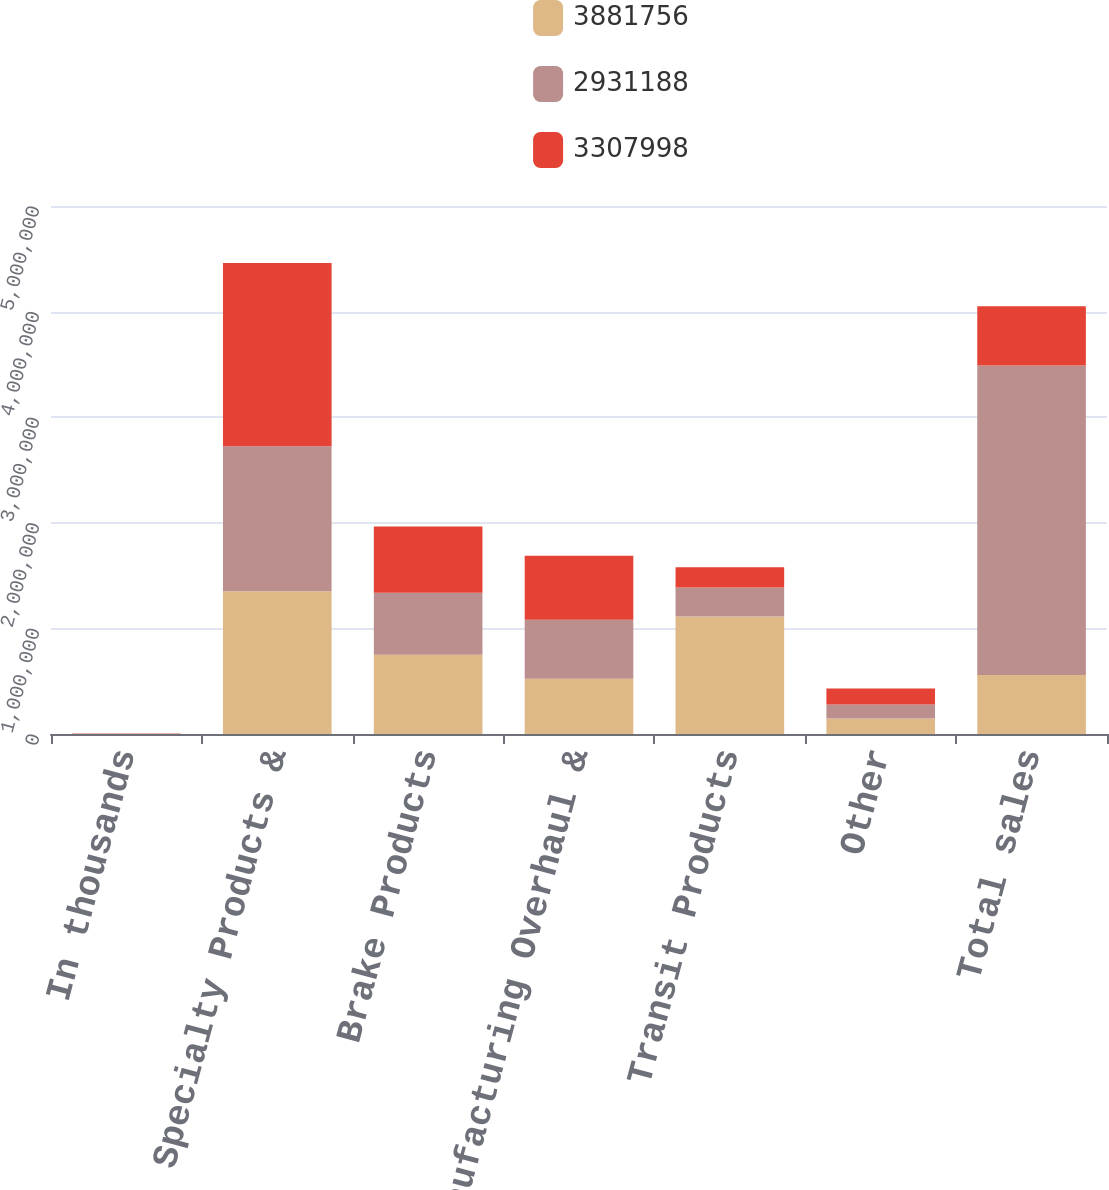Convert chart to OTSL. <chart><loc_0><loc_0><loc_500><loc_500><stacked_bar_chart><ecel><fcel>In thousands<fcel>Specialty Products &<fcel>Brake Products<fcel>Remanufacturing Overhaul &<fcel>Transit Products<fcel>Other<fcel>Total sales<nl><fcel>3.88176e+06<fcel>2017<fcel>1.35073e+06<fcel>749959<fcel>522275<fcel>1.11234e+06<fcel>146455<fcel>559284<nl><fcel>2.93119e+06<fcel>2016<fcel>1.37458e+06<fcel>588081<fcel>559284<fcel>276124<fcel>133119<fcel>2.93119e+06<nl><fcel>3.308e+06<fcel>2015<fcel>1.73388e+06<fcel>627552<fcel>606624<fcel>189581<fcel>150360<fcel>559284<nl></chart> 